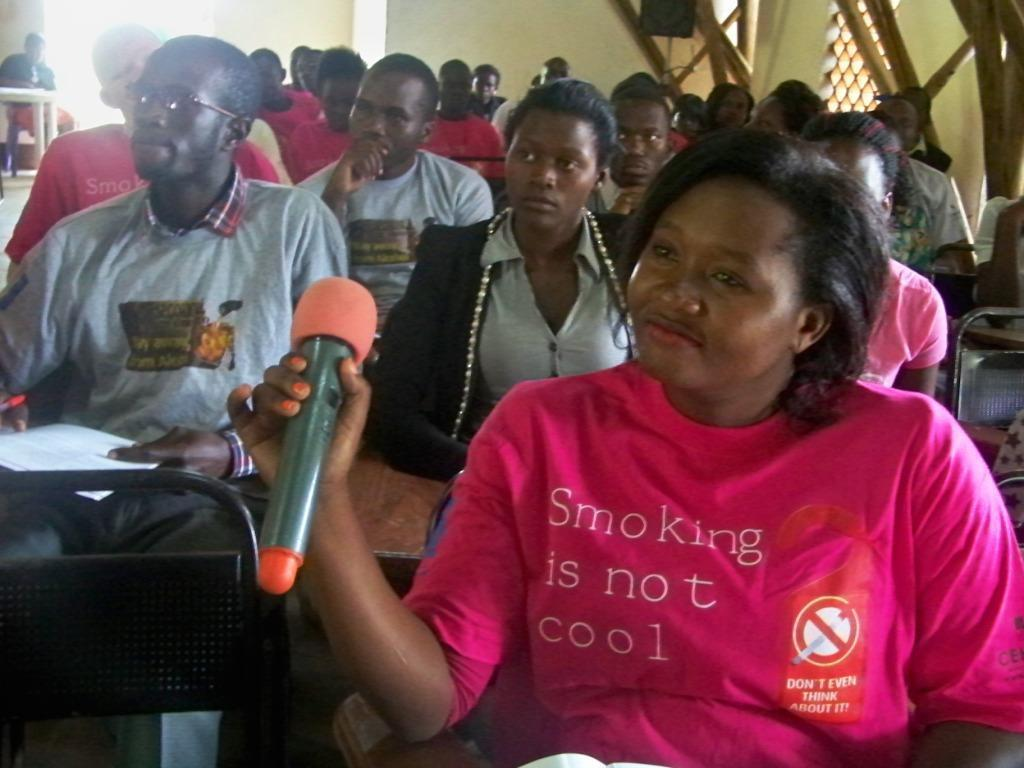What are the people in the image wearing? The persons in the image are wearing clothes. What is the person in the bottom right of the image holding? The person in the bottom right of the image is holding a mic with her hand. What object can be seen in the bottom left of the image? There is a chair in the bottom left of the image. What type of egg is being used as a roof in the image? There is no egg being used as a roof in the image; it does not feature any roof or egg. 